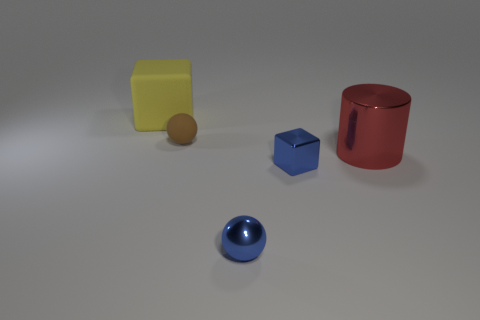Subtract all balls. How many objects are left? 3 Add 4 large metal things. How many objects exist? 9 Subtract all tiny gray metallic blocks. Subtract all large blocks. How many objects are left? 4 Add 3 blue metal things. How many blue metal things are left? 5 Add 3 metal spheres. How many metal spheres exist? 4 Subtract 0 red balls. How many objects are left? 5 